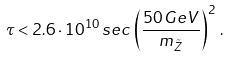Convert formula to latex. <formula><loc_0><loc_0><loc_500><loc_500>\tau < 2 . 6 \cdot 1 0 ^ { 1 0 } \, s e c \, \left ( \frac { 5 0 \, G e V } { m _ { \tilde { Z } } } \right ) ^ { 2 } \, .</formula> 